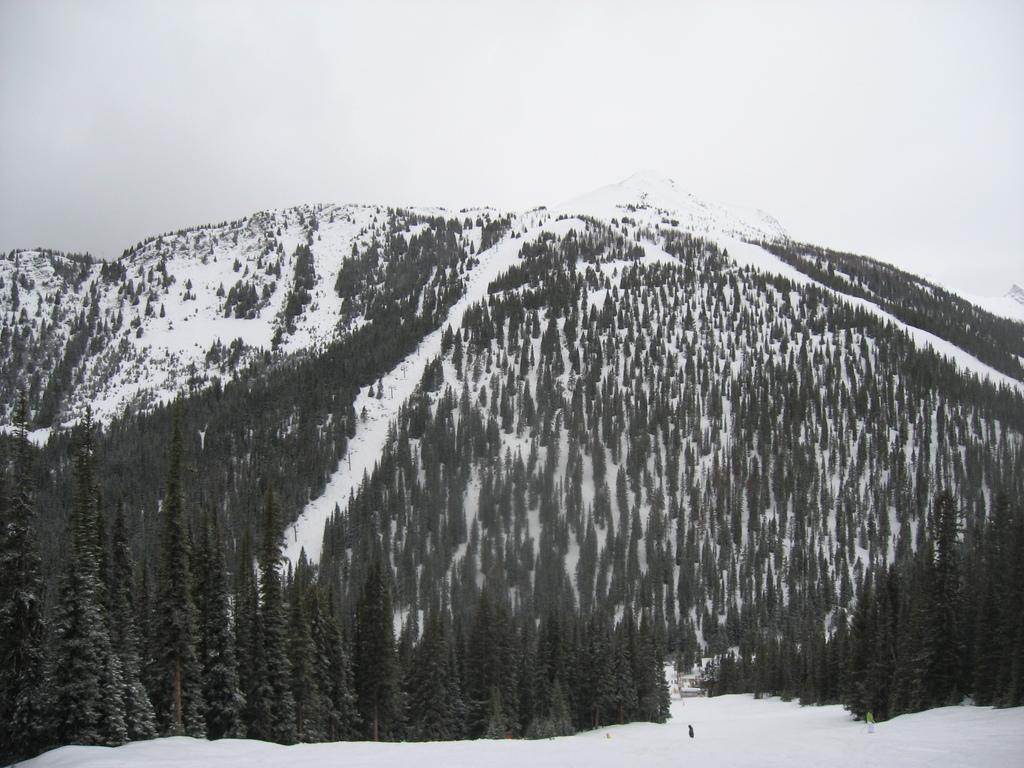What is the main geographical feature in the image? There is a mountain in the image. What is a notable characteristic of the mountain? The mountain has snow. What type of vegetation can be seen in the image? There are trees in the image. What can be seen in the background of the image? The sky is visible in the background of the image. What type of plastic is used to create the surprise on the tray in the image? There is no plastic, surprise, or tray present in the image. 